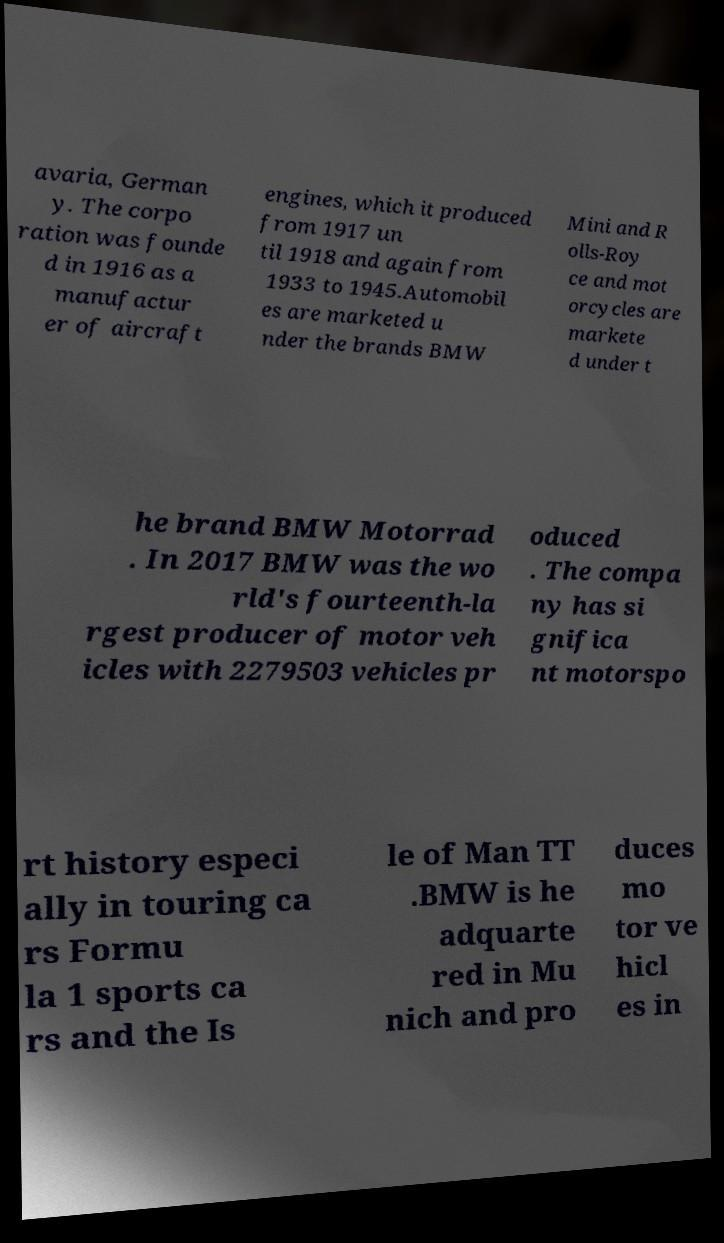Please read and relay the text visible in this image. What does it say? avaria, German y. The corpo ration was founde d in 1916 as a manufactur er of aircraft engines, which it produced from 1917 un til 1918 and again from 1933 to 1945.Automobil es are marketed u nder the brands BMW Mini and R olls-Roy ce and mot orcycles are markete d under t he brand BMW Motorrad . In 2017 BMW was the wo rld's fourteenth-la rgest producer of motor veh icles with 2279503 vehicles pr oduced . The compa ny has si gnifica nt motorspo rt history especi ally in touring ca rs Formu la 1 sports ca rs and the Is le of Man TT .BMW is he adquarte red in Mu nich and pro duces mo tor ve hicl es in 